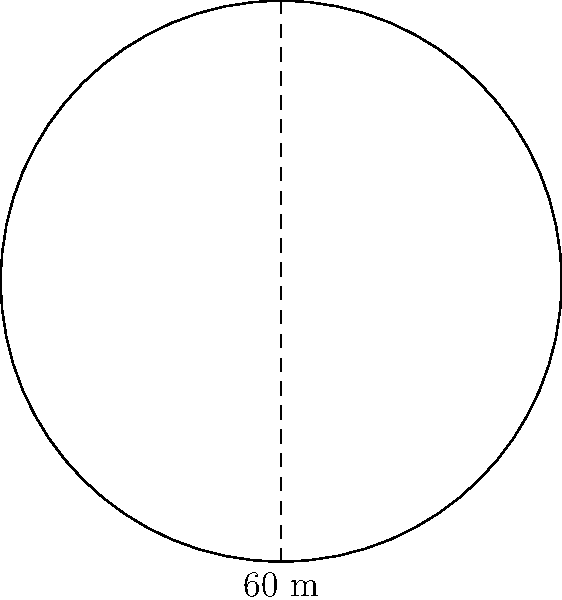As a rodeo arena designer, you're tasked with calculating the area of a circular arena. The arena has a diameter of 60 meters. What is the total area of the arena in square meters? (Use π = 3.14 and round your answer to the nearest whole number.) To calculate the area of a circular rodeo arena, we'll follow these steps:

1) The formula for the area of a circle is:
   $$A = \pi r^2$$
   where $A$ is the area and $r$ is the radius.

2) We're given the diameter (60 m), but we need the radius. The radius is half the diameter:
   $$r = \frac{60}{2} = 30 \text{ m}$$

3) Now we can substitute this into our area formula:
   $$A = \pi (30)^2$$

4) Let's calculate:
   $$A = 3.14 \times 30^2 = 3.14 \times 900 = 2,826 \text{ m}^2$$

5) Rounding to the nearest whole number:
   $$A \approx 2,826 \text{ m}^2$$

Therefore, the total area of the rodeo arena is approximately 2,826 square meters.
Answer: 2,826 m² 